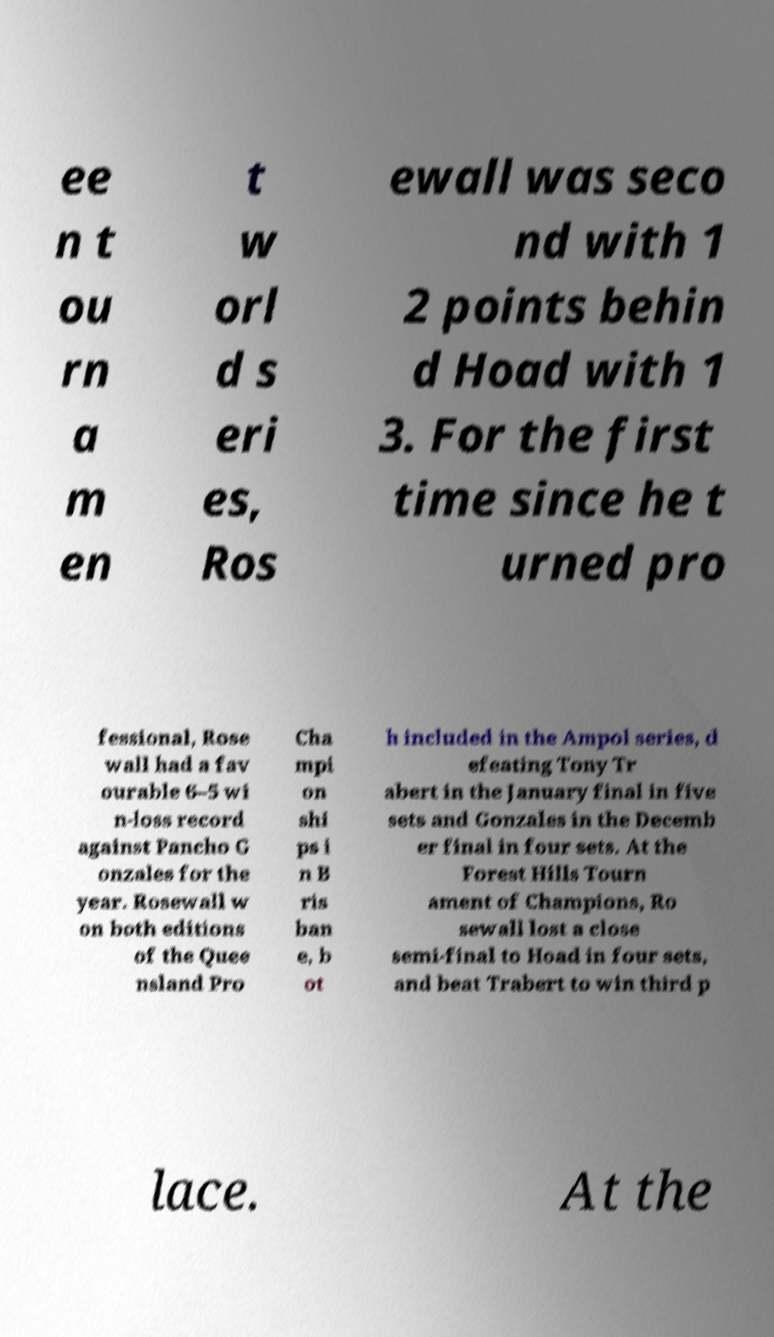I need the written content from this picture converted into text. Can you do that? ee n t ou rn a m en t w orl d s eri es, Ros ewall was seco nd with 1 2 points behin d Hoad with 1 3. For the first time since he t urned pro fessional, Rose wall had a fav ourable 6–5 wi n-loss record against Pancho G onzales for the year. Rosewall w on both editions of the Quee nsland Pro Cha mpi on shi ps i n B ris ban e, b ot h included in the Ampol series, d efeating Tony Tr abert in the January final in five sets and Gonzales in the Decemb er final in four sets. At the Forest Hills Tourn ament of Champions, Ro sewall lost a close semi-final to Hoad in four sets, and beat Trabert to win third p lace. At the 